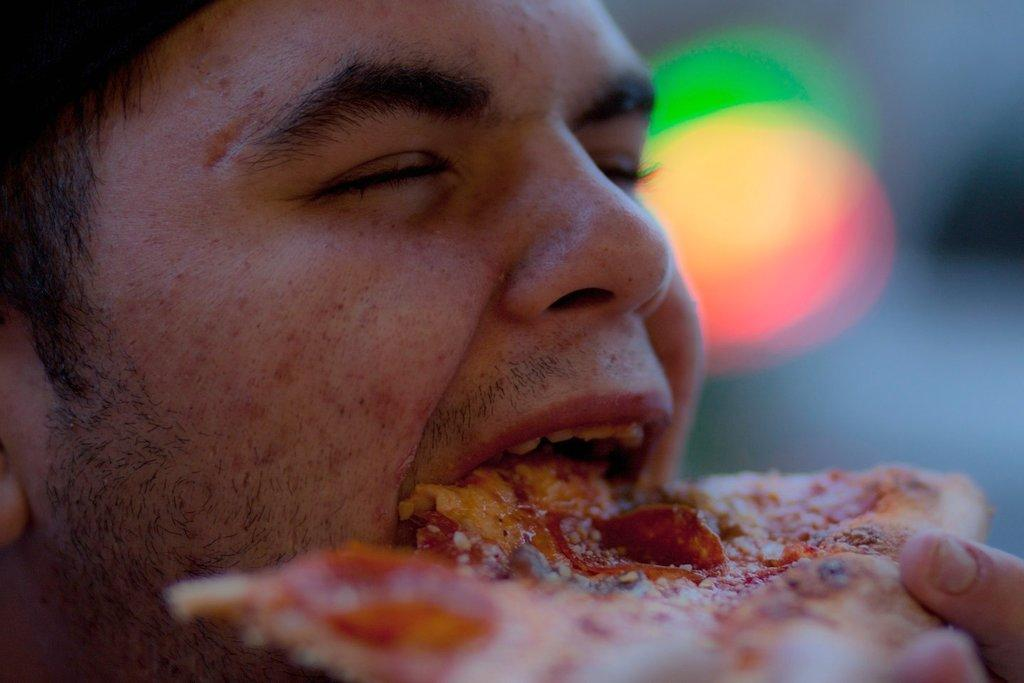Who or what is the main subject in the image? There is a person in the image. What is the person doing in the image? The person is eating food. Where is the person located in the image? The person is located in the center of the image. What type of paper is the person using to eat the food in the image? There is no paper visible in the image, and the person is using their hands or utensils to eat the food. 